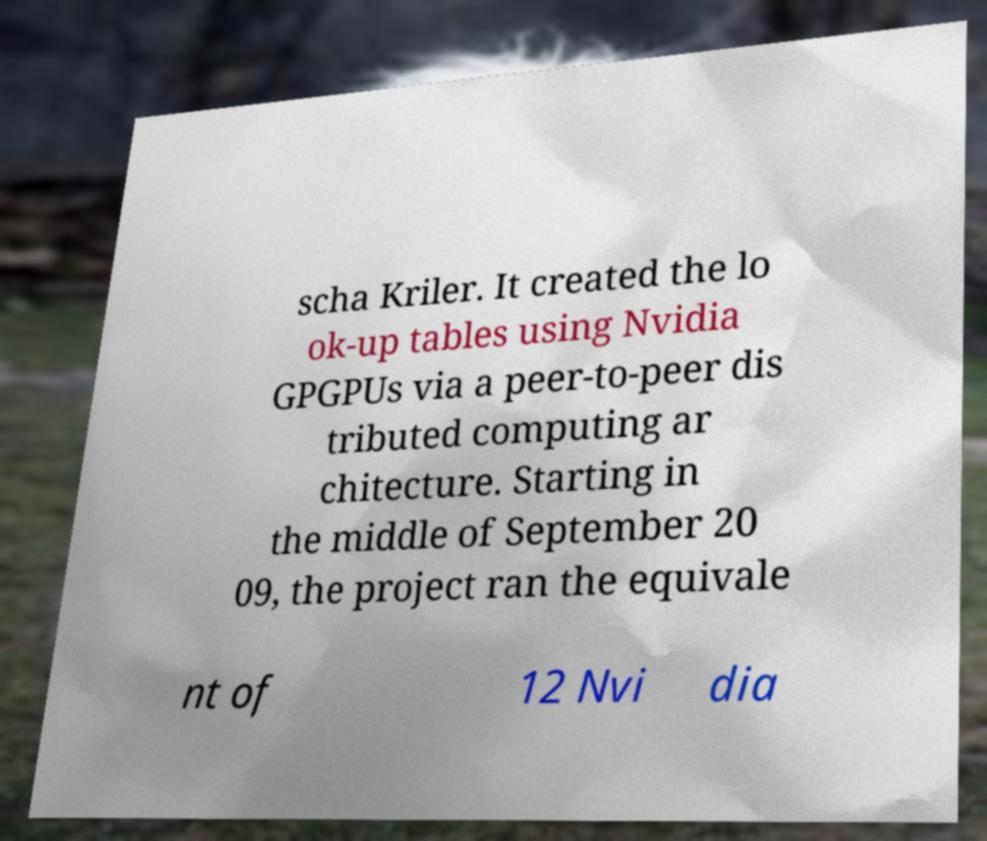For documentation purposes, I need the text within this image transcribed. Could you provide that? scha Kriler. It created the lo ok-up tables using Nvidia GPGPUs via a peer-to-peer dis tributed computing ar chitecture. Starting in the middle of September 20 09, the project ran the equivale nt of 12 Nvi dia 